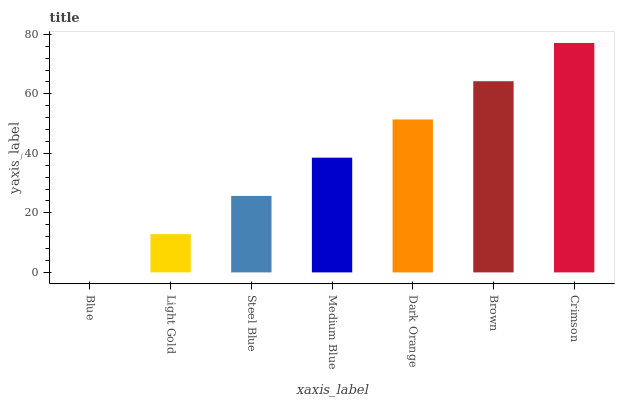Is Blue the minimum?
Answer yes or no. Yes. Is Crimson the maximum?
Answer yes or no. Yes. Is Light Gold the minimum?
Answer yes or no. No. Is Light Gold the maximum?
Answer yes or no. No. Is Light Gold greater than Blue?
Answer yes or no. Yes. Is Blue less than Light Gold?
Answer yes or no. Yes. Is Blue greater than Light Gold?
Answer yes or no. No. Is Light Gold less than Blue?
Answer yes or no. No. Is Medium Blue the high median?
Answer yes or no. Yes. Is Medium Blue the low median?
Answer yes or no. Yes. Is Dark Orange the high median?
Answer yes or no. No. Is Blue the low median?
Answer yes or no. No. 